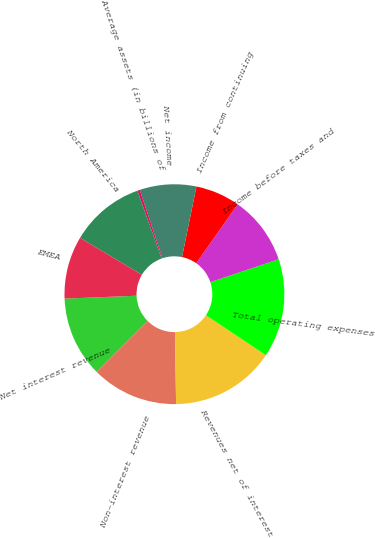<chart> <loc_0><loc_0><loc_500><loc_500><pie_chart><fcel>Net interest revenue<fcel>Non-interest revenue<fcel>Revenues net of interest<fcel>Total operating expenses<fcel>Income before taxes and<fcel>Income from continuing<fcel>Net income<fcel>Average assets (in billions of<fcel>North America<fcel>EMEA<nl><fcel>11.86%<fcel>12.74%<fcel>15.4%<fcel>14.51%<fcel>10.09%<fcel>6.55%<fcel>8.32%<fcel>0.36%<fcel>10.97%<fcel>9.2%<nl></chart> 